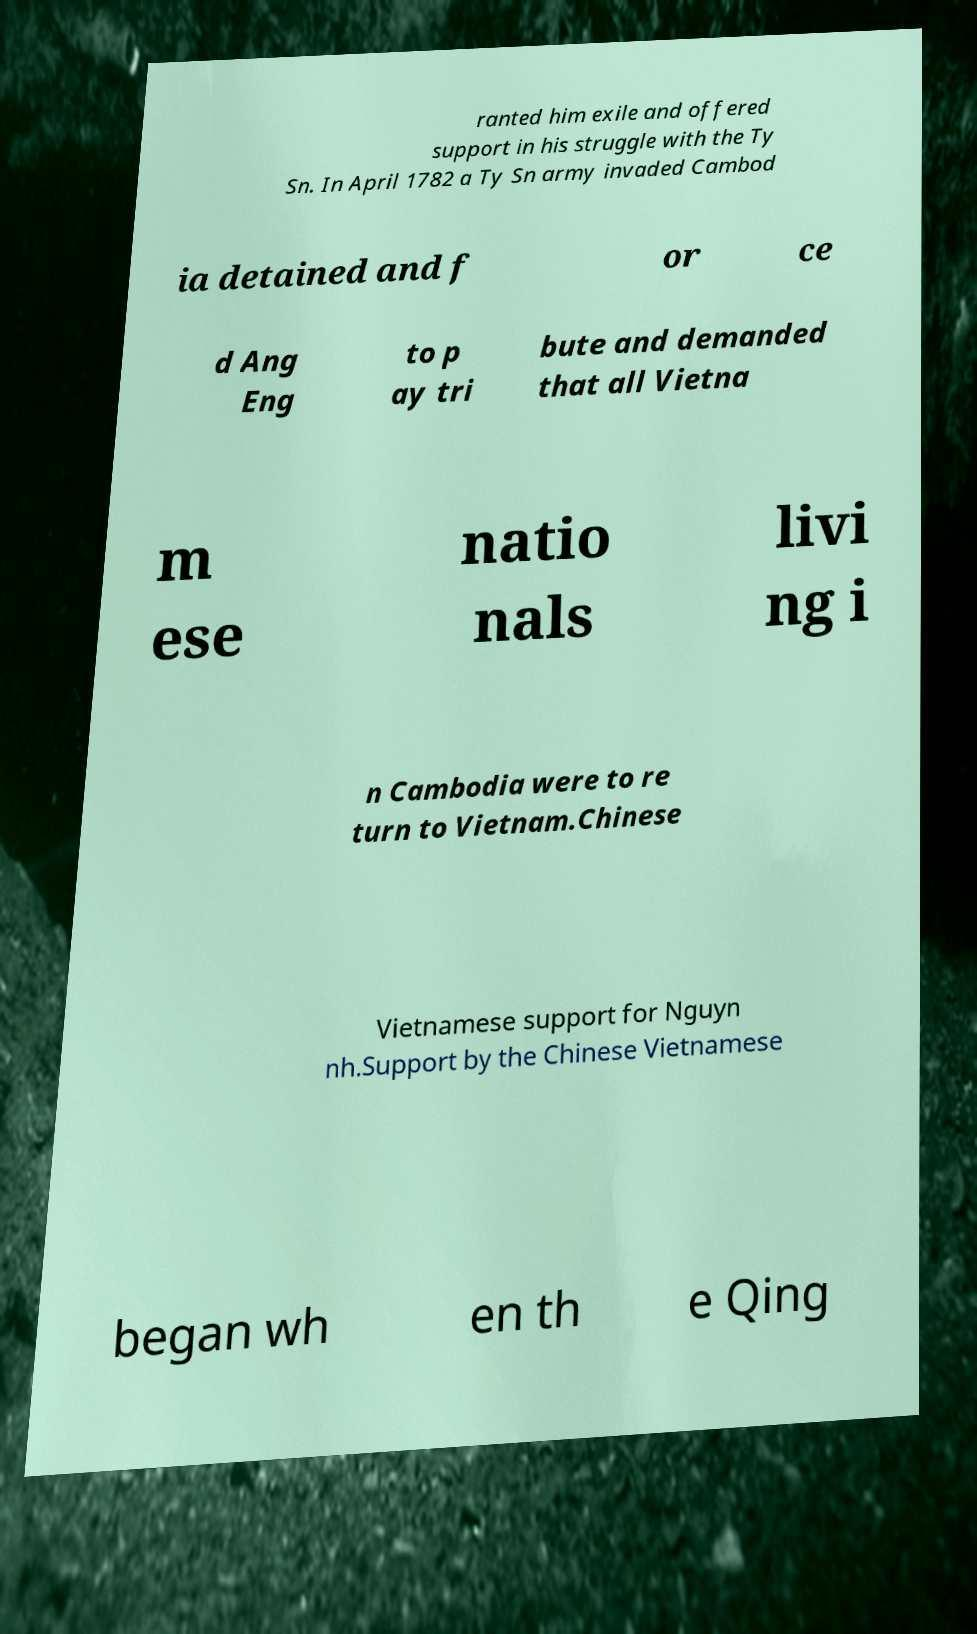I need the written content from this picture converted into text. Can you do that? ranted him exile and offered support in his struggle with the Ty Sn. In April 1782 a Ty Sn army invaded Cambod ia detained and f or ce d Ang Eng to p ay tri bute and demanded that all Vietna m ese natio nals livi ng i n Cambodia were to re turn to Vietnam.Chinese Vietnamese support for Nguyn nh.Support by the Chinese Vietnamese began wh en th e Qing 